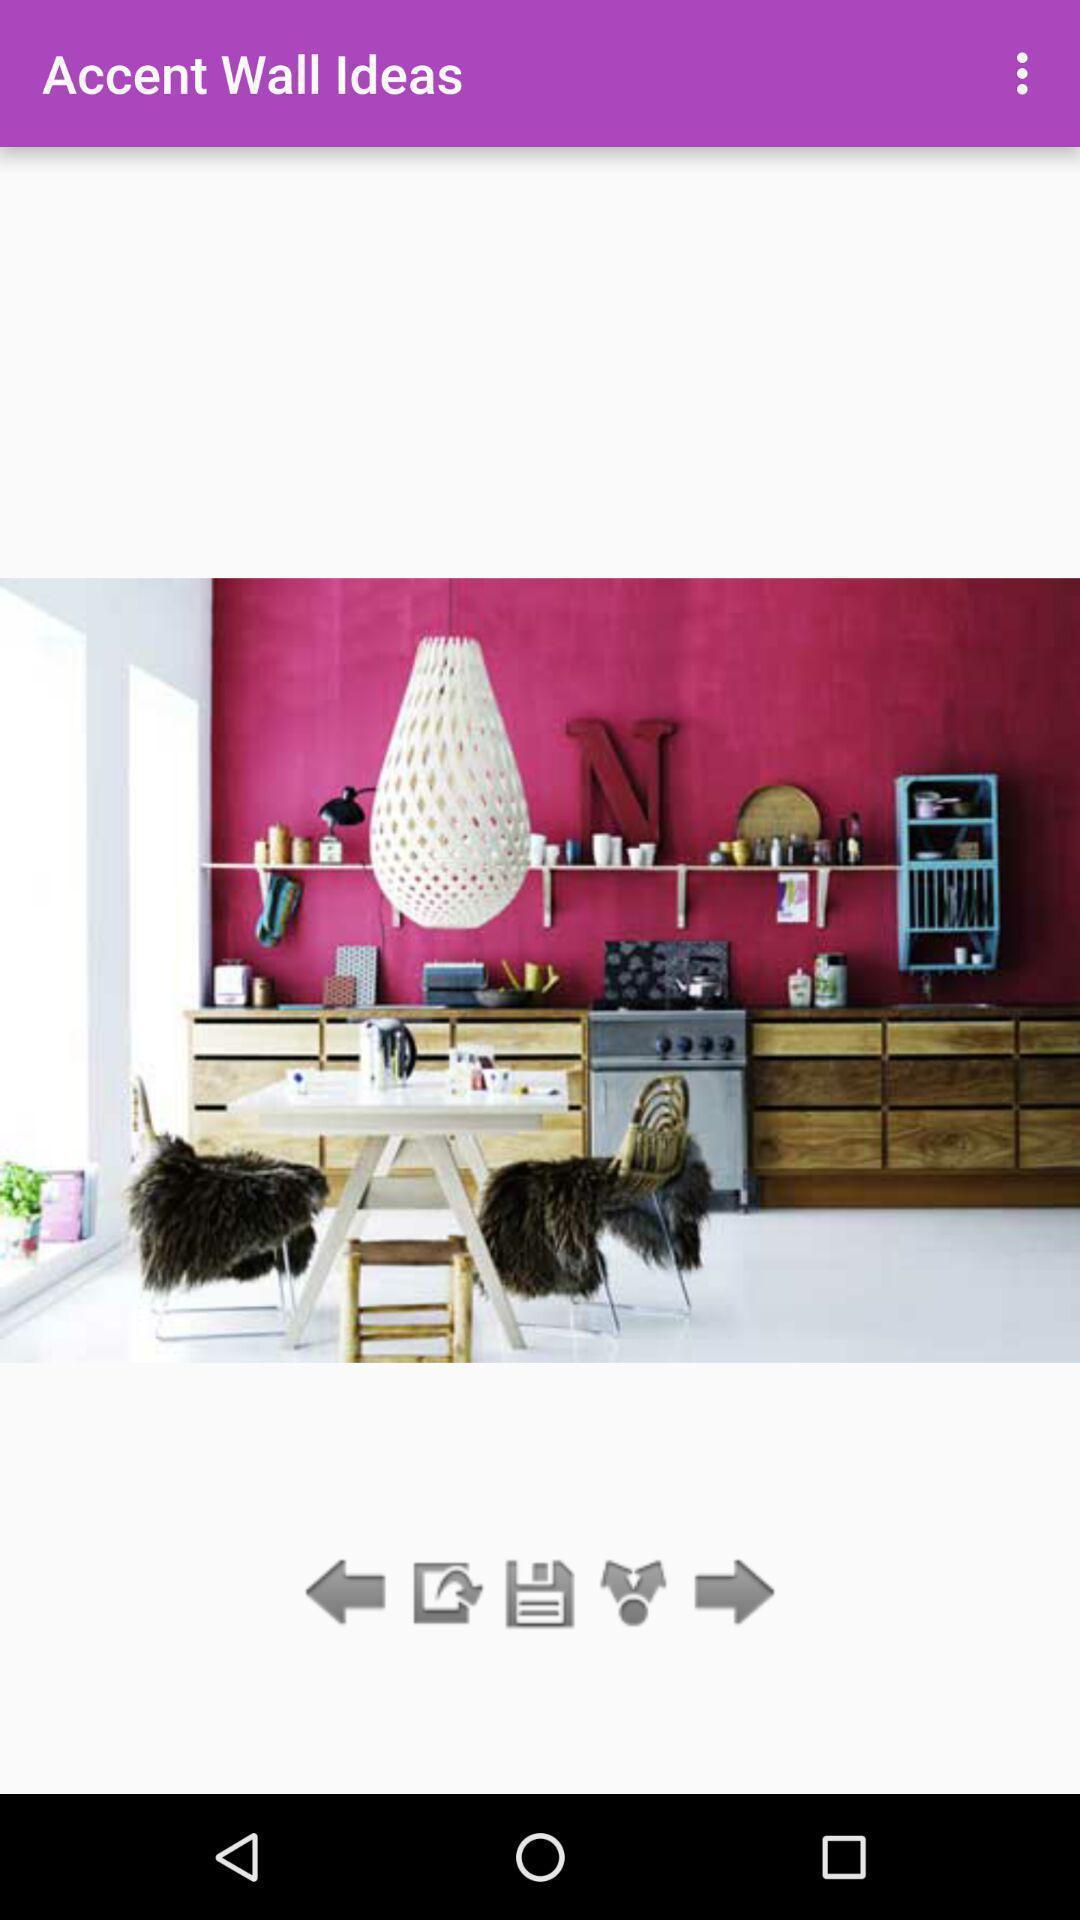Please provide a description for this image. Screen showing wall ideas. 